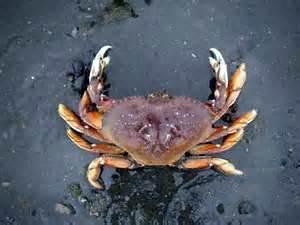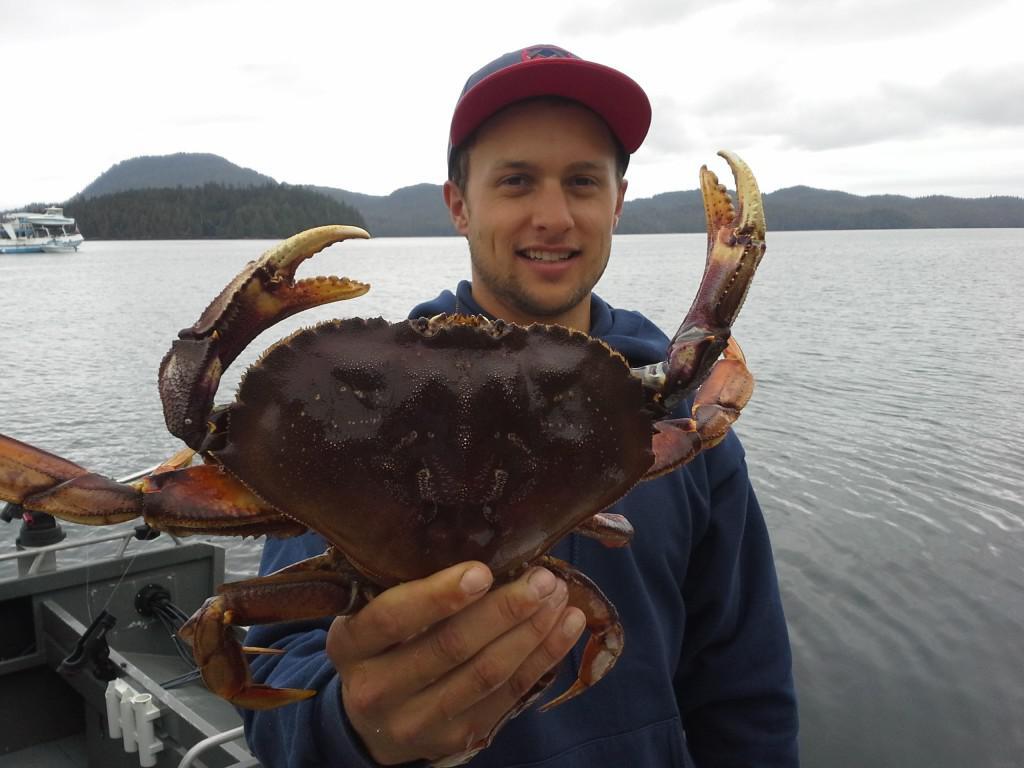The first image is the image on the left, the second image is the image on the right. Examine the images to the left and right. Is the description "In one image, a person wearing a front-brimmed hat and jacket is holding a single large crab with its legs outstretched." accurate? Answer yes or no. Yes. The first image is the image on the left, the second image is the image on the right. Evaluate the accuracy of this statement regarding the images: "The right image features a person in a ball cap holding up a purple crab with the bare hand of the arm on the left.". Is it true? Answer yes or no. Yes. 